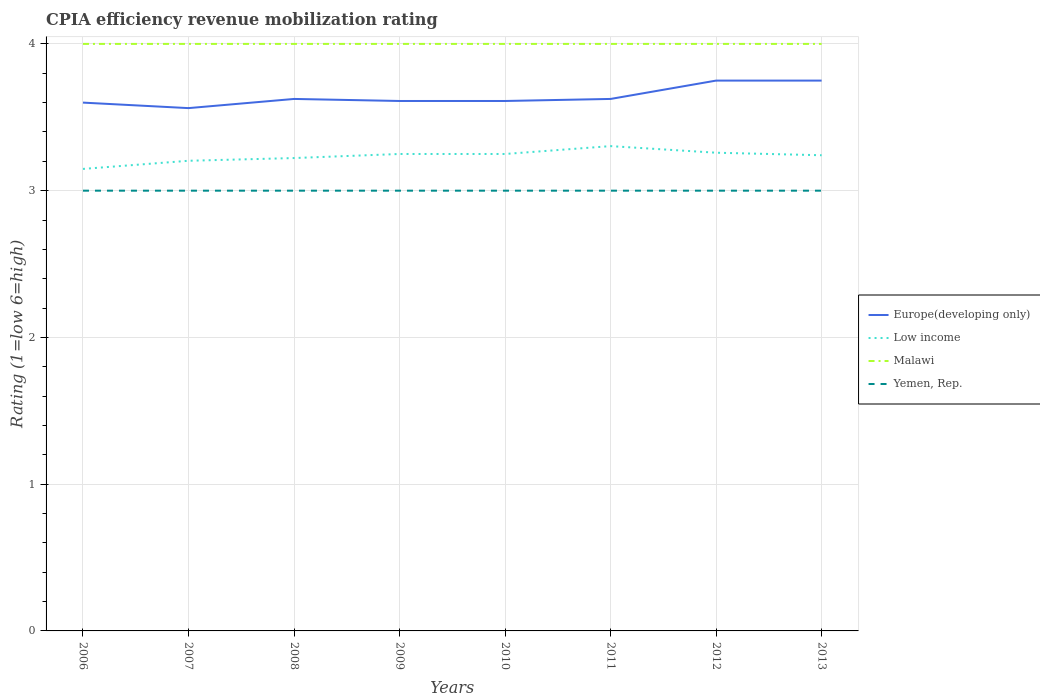Does the line corresponding to Malawi intersect with the line corresponding to Europe(developing only)?
Offer a very short reply. No. Is the number of lines equal to the number of legend labels?
Your answer should be very brief. Yes. Across all years, what is the maximum CPIA rating in Low income?
Ensure brevity in your answer.  3.15. In which year was the CPIA rating in Europe(developing only) maximum?
Your answer should be compact. 2007. What is the total CPIA rating in Europe(developing only) in the graph?
Offer a terse response. -0.02. What is the difference between the highest and the second highest CPIA rating in Malawi?
Your answer should be very brief. 0. Is the CPIA rating in Europe(developing only) strictly greater than the CPIA rating in Malawi over the years?
Provide a short and direct response. Yes. How many years are there in the graph?
Your response must be concise. 8. What is the difference between two consecutive major ticks on the Y-axis?
Offer a very short reply. 1. Does the graph contain any zero values?
Offer a very short reply. No. Does the graph contain grids?
Make the answer very short. Yes. Where does the legend appear in the graph?
Offer a very short reply. Center right. How are the legend labels stacked?
Offer a very short reply. Vertical. What is the title of the graph?
Keep it short and to the point. CPIA efficiency revenue mobilization rating. What is the label or title of the X-axis?
Your answer should be very brief. Years. What is the label or title of the Y-axis?
Your response must be concise. Rating (1=low 6=high). What is the Rating (1=low 6=high) of Low income in 2006?
Offer a very short reply. 3.15. What is the Rating (1=low 6=high) in Yemen, Rep. in 2006?
Ensure brevity in your answer.  3. What is the Rating (1=low 6=high) in Europe(developing only) in 2007?
Your response must be concise. 3.56. What is the Rating (1=low 6=high) of Low income in 2007?
Your answer should be compact. 3.2. What is the Rating (1=low 6=high) in Malawi in 2007?
Keep it short and to the point. 4. What is the Rating (1=low 6=high) of Yemen, Rep. in 2007?
Make the answer very short. 3. What is the Rating (1=low 6=high) of Europe(developing only) in 2008?
Provide a succinct answer. 3.62. What is the Rating (1=low 6=high) in Low income in 2008?
Offer a terse response. 3.22. What is the Rating (1=low 6=high) of Malawi in 2008?
Ensure brevity in your answer.  4. What is the Rating (1=low 6=high) of Europe(developing only) in 2009?
Offer a very short reply. 3.61. What is the Rating (1=low 6=high) of Malawi in 2009?
Ensure brevity in your answer.  4. What is the Rating (1=low 6=high) in Yemen, Rep. in 2009?
Keep it short and to the point. 3. What is the Rating (1=low 6=high) of Europe(developing only) in 2010?
Your response must be concise. 3.61. What is the Rating (1=low 6=high) of Low income in 2010?
Keep it short and to the point. 3.25. What is the Rating (1=low 6=high) of Malawi in 2010?
Offer a very short reply. 4. What is the Rating (1=low 6=high) in Europe(developing only) in 2011?
Your answer should be compact. 3.62. What is the Rating (1=low 6=high) in Low income in 2011?
Ensure brevity in your answer.  3.3. What is the Rating (1=low 6=high) in Malawi in 2011?
Offer a very short reply. 4. What is the Rating (1=low 6=high) in Europe(developing only) in 2012?
Provide a succinct answer. 3.75. What is the Rating (1=low 6=high) of Low income in 2012?
Provide a succinct answer. 3.26. What is the Rating (1=low 6=high) of Europe(developing only) in 2013?
Provide a short and direct response. 3.75. What is the Rating (1=low 6=high) of Low income in 2013?
Offer a terse response. 3.24. What is the Rating (1=low 6=high) in Malawi in 2013?
Your answer should be compact. 4. Across all years, what is the maximum Rating (1=low 6=high) in Europe(developing only)?
Your response must be concise. 3.75. Across all years, what is the maximum Rating (1=low 6=high) in Low income?
Keep it short and to the point. 3.3. Across all years, what is the maximum Rating (1=low 6=high) of Malawi?
Offer a terse response. 4. Across all years, what is the minimum Rating (1=low 6=high) in Europe(developing only)?
Offer a very short reply. 3.56. Across all years, what is the minimum Rating (1=low 6=high) in Low income?
Your response must be concise. 3.15. Across all years, what is the minimum Rating (1=low 6=high) in Malawi?
Your answer should be compact. 4. Across all years, what is the minimum Rating (1=low 6=high) in Yemen, Rep.?
Keep it short and to the point. 3. What is the total Rating (1=low 6=high) of Europe(developing only) in the graph?
Your answer should be compact. 29.13. What is the total Rating (1=low 6=high) in Low income in the graph?
Your answer should be compact. 25.88. What is the total Rating (1=low 6=high) of Malawi in the graph?
Keep it short and to the point. 32. What is the total Rating (1=low 6=high) of Yemen, Rep. in the graph?
Your answer should be compact. 24. What is the difference between the Rating (1=low 6=high) of Europe(developing only) in 2006 and that in 2007?
Ensure brevity in your answer.  0.04. What is the difference between the Rating (1=low 6=high) of Low income in 2006 and that in 2007?
Your response must be concise. -0.06. What is the difference between the Rating (1=low 6=high) of Yemen, Rep. in 2006 and that in 2007?
Your answer should be very brief. 0. What is the difference between the Rating (1=low 6=high) in Europe(developing only) in 2006 and that in 2008?
Offer a very short reply. -0.03. What is the difference between the Rating (1=low 6=high) of Low income in 2006 and that in 2008?
Make the answer very short. -0.07. What is the difference between the Rating (1=low 6=high) in Yemen, Rep. in 2006 and that in 2008?
Offer a terse response. 0. What is the difference between the Rating (1=low 6=high) in Europe(developing only) in 2006 and that in 2009?
Provide a short and direct response. -0.01. What is the difference between the Rating (1=low 6=high) in Low income in 2006 and that in 2009?
Offer a very short reply. -0.1. What is the difference between the Rating (1=low 6=high) in Yemen, Rep. in 2006 and that in 2009?
Offer a very short reply. 0. What is the difference between the Rating (1=low 6=high) of Europe(developing only) in 2006 and that in 2010?
Provide a succinct answer. -0.01. What is the difference between the Rating (1=low 6=high) of Low income in 2006 and that in 2010?
Provide a short and direct response. -0.1. What is the difference between the Rating (1=low 6=high) of Malawi in 2006 and that in 2010?
Make the answer very short. 0. What is the difference between the Rating (1=low 6=high) of Yemen, Rep. in 2006 and that in 2010?
Your answer should be compact. 0. What is the difference between the Rating (1=low 6=high) in Europe(developing only) in 2006 and that in 2011?
Provide a short and direct response. -0.03. What is the difference between the Rating (1=low 6=high) of Low income in 2006 and that in 2011?
Provide a short and direct response. -0.16. What is the difference between the Rating (1=low 6=high) of Yemen, Rep. in 2006 and that in 2011?
Your answer should be very brief. 0. What is the difference between the Rating (1=low 6=high) of Europe(developing only) in 2006 and that in 2012?
Offer a very short reply. -0.15. What is the difference between the Rating (1=low 6=high) in Low income in 2006 and that in 2012?
Keep it short and to the point. -0.11. What is the difference between the Rating (1=low 6=high) of Malawi in 2006 and that in 2012?
Ensure brevity in your answer.  0. What is the difference between the Rating (1=low 6=high) of Yemen, Rep. in 2006 and that in 2012?
Offer a very short reply. 0. What is the difference between the Rating (1=low 6=high) in Europe(developing only) in 2006 and that in 2013?
Ensure brevity in your answer.  -0.15. What is the difference between the Rating (1=low 6=high) of Low income in 2006 and that in 2013?
Offer a terse response. -0.09. What is the difference between the Rating (1=low 6=high) in Malawi in 2006 and that in 2013?
Keep it short and to the point. 0. What is the difference between the Rating (1=low 6=high) in Yemen, Rep. in 2006 and that in 2013?
Provide a succinct answer. 0. What is the difference between the Rating (1=low 6=high) in Europe(developing only) in 2007 and that in 2008?
Your response must be concise. -0.06. What is the difference between the Rating (1=low 6=high) of Low income in 2007 and that in 2008?
Your response must be concise. -0.02. What is the difference between the Rating (1=low 6=high) in Yemen, Rep. in 2007 and that in 2008?
Your answer should be very brief. 0. What is the difference between the Rating (1=low 6=high) in Europe(developing only) in 2007 and that in 2009?
Your answer should be compact. -0.05. What is the difference between the Rating (1=low 6=high) in Low income in 2007 and that in 2009?
Provide a short and direct response. -0.05. What is the difference between the Rating (1=low 6=high) in Yemen, Rep. in 2007 and that in 2009?
Ensure brevity in your answer.  0. What is the difference between the Rating (1=low 6=high) of Europe(developing only) in 2007 and that in 2010?
Offer a terse response. -0.05. What is the difference between the Rating (1=low 6=high) in Low income in 2007 and that in 2010?
Provide a succinct answer. -0.05. What is the difference between the Rating (1=low 6=high) in Europe(developing only) in 2007 and that in 2011?
Give a very brief answer. -0.06. What is the difference between the Rating (1=low 6=high) in Low income in 2007 and that in 2011?
Your answer should be compact. -0.1. What is the difference between the Rating (1=low 6=high) of Malawi in 2007 and that in 2011?
Your response must be concise. 0. What is the difference between the Rating (1=low 6=high) in Europe(developing only) in 2007 and that in 2012?
Your response must be concise. -0.19. What is the difference between the Rating (1=low 6=high) in Low income in 2007 and that in 2012?
Make the answer very short. -0.05. What is the difference between the Rating (1=low 6=high) of Malawi in 2007 and that in 2012?
Your answer should be very brief. 0. What is the difference between the Rating (1=low 6=high) of Europe(developing only) in 2007 and that in 2013?
Make the answer very short. -0.19. What is the difference between the Rating (1=low 6=high) of Low income in 2007 and that in 2013?
Ensure brevity in your answer.  -0.04. What is the difference between the Rating (1=low 6=high) of Malawi in 2007 and that in 2013?
Provide a succinct answer. 0. What is the difference between the Rating (1=low 6=high) of Yemen, Rep. in 2007 and that in 2013?
Keep it short and to the point. 0. What is the difference between the Rating (1=low 6=high) in Europe(developing only) in 2008 and that in 2009?
Provide a succinct answer. 0.01. What is the difference between the Rating (1=low 6=high) of Low income in 2008 and that in 2009?
Your answer should be very brief. -0.03. What is the difference between the Rating (1=low 6=high) in Yemen, Rep. in 2008 and that in 2009?
Offer a very short reply. 0. What is the difference between the Rating (1=low 6=high) in Europe(developing only) in 2008 and that in 2010?
Offer a very short reply. 0.01. What is the difference between the Rating (1=low 6=high) of Low income in 2008 and that in 2010?
Make the answer very short. -0.03. What is the difference between the Rating (1=low 6=high) in Malawi in 2008 and that in 2010?
Provide a short and direct response. 0. What is the difference between the Rating (1=low 6=high) of Europe(developing only) in 2008 and that in 2011?
Make the answer very short. 0. What is the difference between the Rating (1=low 6=high) of Low income in 2008 and that in 2011?
Keep it short and to the point. -0.08. What is the difference between the Rating (1=low 6=high) in Europe(developing only) in 2008 and that in 2012?
Keep it short and to the point. -0.12. What is the difference between the Rating (1=low 6=high) of Low income in 2008 and that in 2012?
Your answer should be compact. -0.04. What is the difference between the Rating (1=low 6=high) of Europe(developing only) in 2008 and that in 2013?
Your answer should be very brief. -0.12. What is the difference between the Rating (1=low 6=high) in Low income in 2008 and that in 2013?
Make the answer very short. -0.02. What is the difference between the Rating (1=low 6=high) of Yemen, Rep. in 2008 and that in 2013?
Your answer should be very brief. 0. What is the difference between the Rating (1=low 6=high) in Europe(developing only) in 2009 and that in 2010?
Your answer should be compact. 0. What is the difference between the Rating (1=low 6=high) in Europe(developing only) in 2009 and that in 2011?
Your answer should be compact. -0.01. What is the difference between the Rating (1=low 6=high) of Low income in 2009 and that in 2011?
Your response must be concise. -0.05. What is the difference between the Rating (1=low 6=high) of Malawi in 2009 and that in 2011?
Offer a terse response. 0. What is the difference between the Rating (1=low 6=high) of Europe(developing only) in 2009 and that in 2012?
Provide a succinct answer. -0.14. What is the difference between the Rating (1=low 6=high) of Low income in 2009 and that in 2012?
Your answer should be very brief. -0.01. What is the difference between the Rating (1=low 6=high) in Yemen, Rep. in 2009 and that in 2012?
Your answer should be very brief. 0. What is the difference between the Rating (1=low 6=high) of Europe(developing only) in 2009 and that in 2013?
Your answer should be very brief. -0.14. What is the difference between the Rating (1=low 6=high) in Low income in 2009 and that in 2013?
Provide a succinct answer. 0.01. What is the difference between the Rating (1=low 6=high) in Malawi in 2009 and that in 2013?
Offer a terse response. 0. What is the difference between the Rating (1=low 6=high) in Yemen, Rep. in 2009 and that in 2013?
Provide a short and direct response. 0. What is the difference between the Rating (1=low 6=high) of Europe(developing only) in 2010 and that in 2011?
Your answer should be very brief. -0.01. What is the difference between the Rating (1=low 6=high) in Low income in 2010 and that in 2011?
Provide a short and direct response. -0.05. What is the difference between the Rating (1=low 6=high) of Malawi in 2010 and that in 2011?
Offer a terse response. 0. What is the difference between the Rating (1=low 6=high) in Yemen, Rep. in 2010 and that in 2011?
Ensure brevity in your answer.  0. What is the difference between the Rating (1=low 6=high) in Europe(developing only) in 2010 and that in 2012?
Your response must be concise. -0.14. What is the difference between the Rating (1=low 6=high) in Low income in 2010 and that in 2012?
Your response must be concise. -0.01. What is the difference between the Rating (1=low 6=high) in Europe(developing only) in 2010 and that in 2013?
Keep it short and to the point. -0.14. What is the difference between the Rating (1=low 6=high) of Low income in 2010 and that in 2013?
Ensure brevity in your answer.  0.01. What is the difference between the Rating (1=low 6=high) in Europe(developing only) in 2011 and that in 2012?
Give a very brief answer. -0.12. What is the difference between the Rating (1=low 6=high) of Low income in 2011 and that in 2012?
Ensure brevity in your answer.  0.04. What is the difference between the Rating (1=low 6=high) in Yemen, Rep. in 2011 and that in 2012?
Keep it short and to the point. 0. What is the difference between the Rating (1=low 6=high) of Europe(developing only) in 2011 and that in 2013?
Make the answer very short. -0.12. What is the difference between the Rating (1=low 6=high) in Low income in 2011 and that in 2013?
Keep it short and to the point. 0.06. What is the difference between the Rating (1=low 6=high) of Yemen, Rep. in 2011 and that in 2013?
Offer a terse response. 0. What is the difference between the Rating (1=low 6=high) in Low income in 2012 and that in 2013?
Your answer should be very brief. 0.02. What is the difference between the Rating (1=low 6=high) of Europe(developing only) in 2006 and the Rating (1=low 6=high) of Low income in 2007?
Keep it short and to the point. 0.4. What is the difference between the Rating (1=low 6=high) in Europe(developing only) in 2006 and the Rating (1=low 6=high) in Yemen, Rep. in 2007?
Your answer should be compact. 0.6. What is the difference between the Rating (1=low 6=high) in Low income in 2006 and the Rating (1=low 6=high) in Malawi in 2007?
Keep it short and to the point. -0.85. What is the difference between the Rating (1=low 6=high) in Low income in 2006 and the Rating (1=low 6=high) in Yemen, Rep. in 2007?
Your answer should be very brief. 0.15. What is the difference between the Rating (1=low 6=high) in Europe(developing only) in 2006 and the Rating (1=low 6=high) in Low income in 2008?
Keep it short and to the point. 0.38. What is the difference between the Rating (1=low 6=high) of Low income in 2006 and the Rating (1=low 6=high) of Malawi in 2008?
Give a very brief answer. -0.85. What is the difference between the Rating (1=low 6=high) of Low income in 2006 and the Rating (1=low 6=high) of Yemen, Rep. in 2008?
Give a very brief answer. 0.15. What is the difference between the Rating (1=low 6=high) of Malawi in 2006 and the Rating (1=low 6=high) of Yemen, Rep. in 2008?
Provide a short and direct response. 1. What is the difference between the Rating (1=low 6=high) in Europe(developing only) in 2006 and the Rating (1=low 6=high) in Low income in 2009?
Offer a terse response. 0.35. What is the difference between the Rating (1=low 6=high) of Europe(developing only) in 2006 and the Rating (1=low 6=high) of Yemen, Rep. in 2009?
Keep it short and to the point. 0.6. What is the difference between the Rating (1=low 6=high) in Low income in 2006 and the Rating (1=low 6=high) in Malawi in 2009?
Make the answer very short. -0.85. What is the difference between the Rating (1=low 6=high) of Low income in 2006 and the Rating (1=low 6=high) of Yemen, Rep. in 2009?
Provide a succinct answer. 0.15. What is the difference between the Rating (1=low 6=high) in Malawi in 2006 and the Rating (1=low 6=high) in Yemen, Rep. in 2009?
Provide a short and direct response. 1. What is the difference between the Rating (1=low 6=high) of Low income in 2006 and the Rating (1=low 6=high) of Malawi in 2010?
Ensure brevity in your answer.  -0.85. What is the difference between the Rating (1=low 6=high) in Low income in 2006 and the Rating (1=low 6=high) in Yemen, Rep. in 2010?
Keep it short and to the point. 0.15. What is the difference between the Rating (1=low 6=high) of Malawi in 2006 and the Rating (1=low 6=high) of Yemen, Rep. in 2010?
Provide a short and direct response. 1. What is the difference between the Rating (1=low 6=high) in Europe(developing only) in 2006 and the Rating (1=low 6=high) in Low income in 2011?
Make the answer very short. 0.3. What is the difference between the Rating (1=low 6=high) of Europe(developing only) in 2006 and the Rating (1=low 6=high) of Malawi in 2011?
Your response must be concise. -0.4. What is the difference between the Rating (1=low 6=high) in Europe(developing only) in 2006 and the Rating (1=low 6=high) in Yemen, Rep. in 2011?
Offer a terse response. 0.6. What is the difference between the Rating (1=low 6=high) in Low income in 2006 and the Rating (1=low 6=high) in Malawi in 2011?
Provide a succinct answer. -0.85. What is the difference between the Rating (1=low 6=high) of Low income in 2006 and the Rating (1=low 6=high) of Yemen, Rep. in 2011?
Ensure brevity in your answer.  0.15. What is the difference between the Rating (1=low 6=high) in Malawi in 2006 and the Rating (1=low 6=high) in Yemen, Rep. in 2011?
Provide a short and direct response. 1. What is the difference between the Rating (1=low 6=high) in Europe(developing only) in 2006 and the Rating (1=low 6=high) in Low income in 2012?
Offer a very short reply. 0.34. What is the difference between the Rating (1=low 6=high) of Europe(developing only) in 2006 and the Rating (1=low 6=high) of Malawi in 2012?
Provide a succinct answer. -0.4. What is the difference between the Rating (1=low 6=high) of Europe(developing only) in 2006 and the Rating (1=low 6=high) of Yemen, Rep. in 2012?
Your answer should be compact. 0.6. What is the difference between the Rating (1=low 6=high) of Low income in 2006 and the Rating (1=low 6=high) of Malawi in 2012?
Ensure brevity in your answer.  -0.85. What is the difference between the Rating (1=low 6=high) in Low income in 2006 and the Rating (1=low 6=high) in Yemen, Rep. in 2012?
Your answer should be very brief. 0.15. What is the difference between the Rating (1=low 6=high) of Malawi in 2006 and the Rating (1=low 6=high) of Yemen, Rep. in 2012?
Ensure brevity in your answer.  1. What is the difference between the Rating (1=low 6=high) of Europe(developing only) in 2006 and the Rating (1=low 6=high) of Low income in 2013?
Give a very brief answer. 0.36. What is the difference between the Rating (1=low 6=high) of Europe(developing only) in 2006 and the Rating (1=low 6=high) of Malawi in 2013?
Make the answer very short. -0.4. What is the difference between the Rating (1=low 6=high) in Europe(developing only) in 2006 and the Rating (1=low 6=high) in Yemen, Rep. in 2013?
Your answer should be compact. 0.6. What is the difference between the Rating (1=low 6=high) of Low income in 2006 and the Rating (1=low 6=high) of Malawi in 2013?
Keep it short and to the point. -0.85. What is the difference between the Rating (1=low 6=high) of Low income in 2006 and the Rating (1=low 6=high) of Yemen, Rep. in 2013?
Make the answer very short. 0.15. What is the difference between the Rating (1=low 6=high) in Europe(developing only) in 2007 and the Rating (1=low 6=high) in Low income in 2008?
Give a very brief answer. 0.34. What is the difference between the Rating (1=low 6=high) of Europe(developing only) in 2007 and the Rating (1=low 6=high) of Malawi in 2008?
Make the answer very short. -0.44. What is the difference between the Rating (1=low 6=high) of Europe(developing only) in 2007 and the Rating (1=low 6=high) of Yemen, Rep. in 2008?
Provide a succinct answer. 0.56. What is the difference between the Rating (1=low 6=high) in Low income in 2007 and the Rating (1=low 6=high) in Malawi in 2008?
Offer a terse response. -0.8. What is the difference between the Rating (1=low 6=high) in Low income in 2007 and the Rating (1=low 6=high) in Yemen, Rep. in 2008?
Make the answer very short. 0.2. What is the difference between the Rating (1=low 6=high) in Malawi in 2007 and the Rating (1=low 6=high) in Yemen, Rep. in 2008?
Offer a very short reply. 1. What is the difference between the Rating (1=low 6=high) of Europe(developing only) in 2007 and the Rating (1=low 6=high) of Low income in 2009?
Provide a succinct answer. 0.31. What is the difference between the Rating (1=low 6=high) of Europe(developing only) in 2007 and the Rating (1=low 6=high) of Malawi in 2009?
Provide a succinct answer. -0.44. What is the difference between the Rating (1=low 6=high) in Europe(developing only) in 2007 and the Rating (1=low 6=high) in Yemen, Rep. in 2009?
Offer a terse response. 0.56. What is the difference between the Rating (1=low 6=high) of Low income in 2007 and the Rating (1=low 6=high) of Malawi in 2009?
Give a very brief answer. -0.8. What is the difference between the Rating (1=low 6=high) of Low income in 2007 and the Rating (1=low 6=high) of Yemen, Rep. in 2009?
Offer a very short reply. 0.2. What is the difference between the Rating (1=low 6=high) of Europe(developing only) in 2007 and the Rating (1=low 6=high) of Low income in 2010?
Make the answer very short. 0.31. What is the difference between the Rating (1=low 6=high) of Europe(developing only) in 2007 and the Rating (1=low 6=high) of Malawi in 2010?
Give a very brief answer. -0.44. What is the difference between the Rating (1=low 6=high) in Europe(developing only) in 2007 and the Rating (1=low 6=high) in Yemen, Rep. in 2010?
Give a very brief answer. 0.56. What is the difference between the Rating (1=low 6=high) of Low income in 2007 and the Rating (1=low 6=high) of Malawi in 2010?
Ensure brevity in your answer.  -0.8. What is the difference between the Rating (1=low 6=high) of Low income in 2007 and the Rating (1=low 6=high) of Yemen, Rep. in 2010?
Your answer should be compact. 0.2. What is the difference between the Rating (1=low 6=high) of Europe(developing only) in 2007 and the Rating (1=low 6=high) of Low income in 2011?
Provide a succinct answer. 0.26. What is the difference between the Rating (1=low 6=high) in Europe(developing only) in 2007 and the Rating (1=low 6=high) in Malawi in 2011?
Your response must be concise. -0.44. What is the difference between the Rating (1=low 6=high) in Europe(developing only) in 2007 and the Rating (1=low 6=high) in Yemen, Rep. in 2011?
Your answer should be compact. 0.56. What is the difference between the Rating (1=low 6=high) of Low income in 2007 and the Rating (1=low 6=high) of Malawi in 2011?
Ensure brevity in your answer.  -0.8. What is the difference between the Rating (1=low 6=high) of Low income in 2007 and the Rating (1=low 6=high) of Yemen, Rep. in 2011?
Keep it short and to the point. 0.2. What is the difference between the Rating (1=low 6=high) in Europe(developing only) in 2007 and the Rating (1=low 6=high) in Low income in 2012?
Your response must be concise. 0.3. What is the difference between the Rating (1=low 6=high) in Europe(developing only) in 2007 and the Rating (1=low 6=high) in Malawi in 2012?
Your response must be concise. -0.44. What is the difference between the Rating (1=low 6=high) in Europe(developing only) in 2007 and the Rating (1=low 6=high) in Yemen, Rep. in 2012?
Give a very brief answer. 0.56. What is the difference between the Rating (1=low 6=high) in Low income in 2007 and the Rating (1=low 6=high) in Malawi in 2012?
Offer a terse response. -0.8. What is the difference between the Rating (1=low 6=high) of Low income in 2007 and the Rating (1=low 6=high) of Yemen, Rep. in 2012?
Make the answer very short. 0.2. What is the difference between the Rating (1=low 6=high) in Europe(developing only) in 2007 and the Rating (1=low 6=high) in Low income in 2013?
Your answer should be compact. 0.32. What is the difference between the Rating (1=low 6=high) of Europe(developing only) in 2007 and the Rating (1=low 6=high) of Malawi in 2013?
Keep it short and to the point. -0.44. What is the difference between the Rating (1=low 6=high) in Europe(developing only) in 2007 and the Rating (1=low 6=high) in Yemen, Rep. in 2013?
Your answer should be compact. 0.56. What is the difference between the Rating (1=low 6=high) in Low income in 2007 and the Rating (1=low 6=high) in Malawi in 2013?
Provide a short and direct response. -0.8. What is the difference between the Rating (1=low 6=high) of Low income in 2007 and the Rating (1=low 6=high) of Yemen, Rep. in 2013?
Provide a succinct answer. 0.2. What is the difference between the Rating (1=low 6=high) of Malawi in 2007 and the Rating (1=low 6=high) of Yemen, Rep. in 2013?
Keep it short and to the point. 1. What is the difference between the Rating (1=low 6=high) in Europe(developing only) in 2008 and the Rating (1=low 6=high) in Low income in 2009?
Offer a terse response. 0.38. What is the difference between the Rating (1=low 6=high) of Europe(developing only) in 2008 and the Rating (1=low 6=high) of Malawi in 2009?
Make the answer very short. -0.38. What is the difference between the Rating (1=low 6=high) in Europe(developing only) in 2008 and the Rating (1=low 6=high) in Yemen, Rep. in 2009?
Offer a terse response. 0.62. What is the difference between the Rating (1=low 6=high) in Low income in 2008 and the Rating (1=low 6=high) in Malawi in 2009?
Ensure brevity in your answer.  -0.78. What is the difference between the Rating (1=low 6=high) of Low income in 2008 and the Rating (1=low 6=high) of Yemen, Rep. in 2009?
Provide a succinct answer. 0.22. What is the difference between the Rating (1=low 6=high) of Malawi in 2008 and the Rating (1=low 6=high) of Yemen, Rep. in 2009?
Offer a very short reply. 1. What is the difference between the Rating (1=low 6=high) of Europe(developing only) in 2008 and the Rating (1=low 6=high) of Malawi in 2010?
Ensure brevity in your answer.  -0.38. What is the difference between the Rating (1=low 6=high) of Europe(developing only) in 2008 and the Rating (1=low 6=high) of Yemen, Rep. in 2010?
Your response must be concise. 0.62. What is the difference between the Rating (1=low 6=high) in Low income in 2008 and the Rating (1=low 6=high) in Malawi in 2010?
Your answer should be compact. -0.78. What is the difference between the Rating (1=low 6=high) in Low income in 2008 and the Rating (1=low 6=high) in Yemen, Rep. in 2010?
Give a very brief answer. 0.22. What is the difference between the Rating (1=low 6=high) in Europe(developing only) in 2008 and the Rating (1=low 6=high) in Low income in 2011?
Give a very brief answer. 0.32. What is the difference between the Rating (1=low 6=high) of Europe(developing only) in 2008 and the Rating (1=low 6=high) of Malawi in 2011?
Offer a very short reply. -0.38. What is the difference between the Rating (1=low 6=high) of Low income in 2008 and the Rating (1=low 6=high) of Malawi in 2011?
Provide a short and direct response. -0.78. What is the difference between the Rating (1=low 6=high) in Low income in 2008 and the Rating (1=low 6=high) in Yemen, Rep. in 2011?
Ensure brevity in your answer.  0.22. What is the difference between the Rating (1=low 6=high) in Europe(developing only) in 2008 and the Rating (1=low 6=high) in Low income in 2012?
Offer a very short reply. 0.37. What is the difference between the Rating (1=low 6=high) in Europe(developing only) in 2008 and the Rating (1=low 6=high) in Malawi in 2012?
Make the answer very short. -0.38. What is the difference between the Rating (1=low 6=high) in Low income in 2008 and the Rating (1=low 6=high) in Malawi in 2012?
Your response must be concise. -0.78. What is the difference between the Rating (1=low 6=high) of Low income in 2008 and the Rating (1=low 6=high) of Yemen, Rep. in 2012?
Provide a succinct answer. 0.22. What is the difference between the Rating (1=low 6=high) in Malawi in 2008 and the Rating (1=low 6=high) in Yemen, Rep. in 2012?
Give a very brief answer. 1. What is the difference between the Rating (1=low 6=high) of Europe(developing only) in 2008 and the Rating (1=low 6=high) of Low income in 2013?
Your answer should be compact. 0.38. What is the difference between the Rating (1=low 6=high) in Europe(developing only) in 2008 and the Rating (1=low 6=high) in Malawi in 2013?
Provide a short and direct response. -0.38. What is the difference between the Rating (1=low 6=high) in Low income in 2008 and the Rating (1=low 6=high) in Malawi in 2013?
Offer a terse response. -0.78. What is the difference between the Rating (1=low 6=high) of Low income in 2008 and the Rating (1=low 6=high) of Yemen, Rep. in 2013?
Give a very brief answer. 0.22. What is the difference between the Rating (1=low 6=high) in Malawi in 2008 and the Rating (1=low 6=high) in Yemen, Rep. in 2013?
Ensure brevity in your answer.  1. What is the difference between the Rating (1=low 6=high) in Europe(developing only) in 2009 and the Rating (1=low 6=high) in Low income in 2010?
Make the answer very short. 0.36. What is the difference between the Rating (1=low 6=high) of Europe(developing only) in 2009 and the Rating (1=low 6=high) of Malawi in 2010?
Your response must be concise. -0.39. What is the difference between the Rating (1=low 6=high) of Europe(developing only) in 2009 and the Rating (1=low 6=high) of Yemen, Rep. in 2010?
Your response must be concise. 0.61. What is the difference between the Rating (1=low 6=high) in Low income in 2009 and the Rating (1=low 6=high) in Malawi in 2010?
Your answer should be very brief. -0.75. What is the difference between the Rating (1=low 6=high) of Europe(developing only) in 2009 and the Rating (1=low 6=high) of Low income in 2011?
Provide a succinct answer. 0.31. What is the difference between the Rating (1=low 6=high) of Europe(developing only) in 2009 and the Rating (1=low 6=high) of Malawi in 2011?
Your response must be concise. -0.39. What is the difference between the Rating (1=low 6=high) of Europe(developing only) in 2009 and the Rating (1=low 6=high) of Yemen, Rep. in 2011?
Your response must be concise. 0.61. What is the difference between the Rating (1=low 6=high) of Low income in 2009 and the Rating (1=low 6=high) of Malawi in 2011?
Ensure brevity in your answer.  -0.75. What is the difference between the Rating (1=low 6=high) of Europe(developing only) in 2009 and the Rating (1=low 6=high) of Low income in 2012?
Offer a terse response. 0.35. What is the difference between the Rating (1=low 6=high) in Europe(developing only) in 2009 and the Rating (1=low 6=high) in Malawi in 2012?
Provide a short and direct response. -0.39. What is the difference between the Rating (1=low 6=high) in Europe(developing only) in 2009 and the Rating (1=low 6=high) in Yemen, Rep. in 2012?
Keep it short and to the point. 0.61. What is the difference between the Rating (1=low 6=high) in Low income in 2009 and the Rating (1=low 6=high) in Malawi in 2012?
Provide a short and direct response. -0.75. What is the difference between the Rating (1=low 6=high) in Malawi in 2009 and the Rating (1=low 6=high) in Yemen, Rep. in 2012?
Offer a terse response. 1. What is the difference between the Rating (1=low 6=high) in Europe(developing only) in 2009 and the Rating (1=low 6=high) in Low income in 2013?
Provide a short and direct response. 0.37. What is the difference between the Rating (1=low 6=high) of Europe(developing only) in 2009 and the Rating (1=low 6=high) of Malawi in 2013?
Your response must be concise. -0.39. What is the difference between the Rating (1=low 6=high) in Europe(developing only) in 2009 and the Rating (1=low 6=high) in Yemen, Rep. in 2013?
Give a very brief answer. 0.61. What is the difference between the Rating (1=low 6=high) of Low income in 2009 and the Rating (1=low 6=high) of Malawi in 2013?
Your answer should be very brief. -0.75. What is the difference between the Rating (1=low 6=high) of Low income in 2009 and the Rating (1=low 6=high) of Yemen, Rep. in 2013?
Give a very brief answer. 0.25. What is the difference between the Rating (1=low 6=high) of Malawi in 2009 and the Rating (1=low 6=high) of Yemen, Rep. in 2013?
Offer a very short reply. 1. What is the difference between the Rating (1=low 6=high) in Europe(developing only) in 2010 and the Rating (1=low 6=high) in Low income in 2011?
Give a very brief answer. 0.31. What is the difference between the Rating (1=low 6=high) in Europe(developing only) in 2010 and the Rating (1=low 6=high) in Malawi in 2011?
Keep it short and to the point. -0.39. What is the difference between the Rating (1=low 6=high) in Europe(developing only) in 2010 and the Rating (1=low 6=high) in Yemen, Rep. in 2011?
Your response must be concise. 0.61. What is the difference between the Rating (1=low 6=high) in Low income in 2010 and the Rating (1=low 6=high) in Malawi in 2011?
Your answer should be compact. -0.75. What is the difference between the Rating (1=low 6=high) of Europe(developing only) in 2010 and the Rating (1=low 6=high) of Low income in 2012?
Your response must be concise. 0.35. What is the difference between the Rating (1=low 6=high) in Europe(developing only) in 2010 and the Rating (1=low 6=high) in Malawi in 2012?
Provide a short and direct response. -0.39. What is the difference between the Rating (1=low 6=high) of Europe(developing only) in 2010 and the Rating (1=low 6=high) of Yemen, Rep. in 2012?
Your answer should be compact. 0.61. What is the difference between the Rating (1=low 6=high) in Low income in 2010 and the Rating (1=low 6=high) in Malawi in 2012?
Provide a short and direct response. -0.75. What is the difference between the Rating (1=low 6=high) of Low income in 2010 and the Rating (1=low 6=high) of Yemen, Rep. in 2012?
Offer a very short reply. 0.25. What is the difference between the Rating (1=low 6=high) in Malawi in 2010 and the Rating (1=low 6=high) in Yemen, Rep. in 2012?
Offer a terse response. 1. What is the difference between the Rating (1=low 6=high) of Europe(developing only) in 2010 and the Rating (1=low 6=high) of Low income in 2013?
Provide a short and direct response. 0.37. What is the difference between the Rating (1=low 6=high) of Europe(developing only) in 2010 and the Rating (1=low 6=high) of Malawi in 2013?
Provide a succinct answer. -0.39. What is the difference between the Rating (1=low 6=high) in Europe(developing only) in 2010 and the Rating (1=low 6=high) in Yemen, Rep. in 2013?
Keep it short and to the point. 0.61. What is the difference between the Rating (1=low 6=high) of Low income in 2010 and the Rating (1=low 6=high) of Malawi in 2013?
Keep it short and to the point. -0.75. What is the difference between the Rating (1=low 6=high) of Europe(developing only) in 2011 and the Rating (1=low 6=high) of Low income in 2012?
Your answer should be compact. 0.37. What is the difference between the Rating (1=low 6=high) in Europe(developing only) in 2011 and the Rating (1=low 6=high) in Malawi in 2012?
Provide a short and direct response. -0.38. What is the difference between the Rating (1=low 6=high) in Low income in 2011 and the Rating (1=low 6=high) in Malawi in 2012?
Your answer should be compact. -0.7. What is the difference between the Rating (1=low 6=high) in Low income in 2011 and the Rating (1=low 6=high) in Yemen, Rep. in 2012?
Your answer should be compact. 0.3. What is the difference between the Rating (1=low 6=high) of Malawi in 2011 and the Rating (1=low 6=high) of Yemen, Rep. in 2012?
Keep it short and to the point. 1. What is the difference between the Rating (1=low 6=high) in Europe(developing only) in 2011 and the Rating (1=low 6=high) in Low income in 2013?
Make the answer very short. 0.38. What is the difference between the Rating (1=low 6=high) of Europe(developing only) in 2011 and the Rating (1=low 6=high) of Malawi in 2013?
Provide a succinct answer. -0.38. What is the difference between the Rating (1=low 6=high) in Low income in 2011 and the Rating (1=low 6=high) in Malawi in 2013?
Ensure brevity in your answer.  -0.7. What is the difference between the Rating (1=low 6=high) of Low income in 2011 and the Rating (1=low 6=high) of Yemen, Rep. in 2013?
Give a very brief answer. 0.3. What is the difference between the Rating (1=low 6=high) in Europe(developing only) in 2012 and the Rating (1=low 6=high) in Low income in 2013?
Give a very brief answer. 0.51. What is the difference between the Rating (1=low 6=high) in Europe(developing only) in 2012 and the Rating (1=low 6=high) in Malawi in 2013?
Offer a terse response. -0.25. What is the difference between the Rating (1=low 6=high) in Europe(developing only) in 2012 and the Rating (1=low 6=high) in Yemen, Rep. in 2013?
Your response must be concise. 0.75. What is the difference between the Rating (1=low 6=high) in Low income in 2012 and the Rating (1=low 6=high) in Malawi in 2013?
Make the answer very short. -0.74. What is the difference between the Rating (1=low 6=high) of Low income in 2012 and the Rating (1=low 6=high) of Yemen, Rep. in 2013?
Your answer should be very brief. 0.26. What is the difference between the Rating (1=low 6=high) in Malawi in 2012 and the Rating (1=low 6=high) in Yemen, Rep. in 2013?
Give a very brief answer. 1. What is the average Rating (1=low 6=high) in Europe(developing only) per year?
Your answer should be compact. 3.64. What is the average Rating (1=low 6=high) in Low income per year?
Your answer should be very brief. 3.23. What is the average Rating (1=low 6=high) in Malawi per year?
Ensure brevity in your answer.  4. What is the average Rating (1=low 6=high) in Yemen, Rep. per year?
Provide a short and direct response. 3. In the year 2006, what is the difference between the Rating (1=low 6=high) in Europe(developing only) and Rating (1=low 6=high) in Low income?
Your response must be concise. 0.45. In the year 2006, what is the difference between the Rating (1=low 6=high) in Europe(developing only) and Rating (1=low 6=high) in Yemen, Rep.?
Keep it short and to the point. 0.6. In the year 2006, what is the difference between the Rating (1=low 6=high) in Low income and Rating (1=low 6=high) in Malawi?
Provide a short and direct response. -0.85. In the year 2006, what is the difference between the Rating (1=low 6=high) in Low income and Rating (1=low 6=high) in Yemen, Rep.?
Offer a terse response. 0.15. In the year 2007, what is the difference between the Rating (1=low 6=high) in Europe(developing only) and Rating (1=low 6=high) in Low income?
Ensure brevity in your answer.  0.36. In the year 2007, what is the difference between the Rating (1=low 6=high) in Europe(developing only) and Rating (1=low 6=high) in Malawi?
Your answer should be compact. -0.44. In the year 2007, what is the difference between the Rating (1=low 6=high) of Europe(developing only) and Rating (1=low 6=high) of Yemen, Rep.?
Your response must be concise. 0.56. In the year 2007, what is the difference between the Rating (1=low 6=high) of Low income and Rating (1=low 6=high) of Malawi?
Your answer should be very brief. -0.8. In the year 2007, what is the difference between the Rating (1=low 6=high) of Low income and Rating (1=low 6=high) of Yemen, Rep.?
Give a very brief answer. 0.2. In the year 2008, what is the difference between the Rating (1=low 6=high) in Europe(developing only) and Rating (1=low 6=high) in Low income?
Ensure brevity in your answer.  0.4. In the year 2008, what is the difference between the Rating (1=low 6=high) in Europe(developing only) and Rating (1=low 6=high) in Malawi?
Your answer should be very brief. -0.38. In the year 2008, what is the difference between the Rating (1=low 6=high) of Europe(developing only) and Rating (1=low 6=high) of Yemen, Rep.?
Your answer should be compact. 0.62. In the year 2008, what is the difference between the Rating (1=low 6=high) of Low income and Rating (1=low 6=high) of Malawi?
Provide a succinct answer. -0.78. In the year 2008, what is the difference between the Rating (1=low 6=high) in Low income and Rating (1=low 6=high) in Yemen, Rep.?
Offer a terse response. 0.22. In the year 2008, what is the difference between the Rating (1=low 6=high) of Malawi and Rating (1=low 6=high) of Yemen, Rep.?
Provide a succinct answer. 1. In the year 2009, what is the difference between the Rating (1=low 6=high) of Europe(developing only) and Rating (1=low 6=high) of Low income?
Offer a very short reply. 0.36. In the year 2009, what is the difference between the Rating (1=low 6=high) of Europe(developing only) and Rating (1=low 6=high) of Malawi?
Provide a succinct answer. -0.39. In the year 2009, what is the difference between the Rating (1=low 6=high) in Europe(developing only) and Rating (1=low 6=high) in Yemen, Rep.?
Give a very brief answer. 0.61. In the year 2009, what is the difference between the Rating (1=low 6=high) in Low income and Rating (1=low 6=high) in Malawi?
Your answer should be very brief. -0.75. In the year 2009, what is the difference between the Rating (1=low 6=high) in Malawi and Rating (1=low 6=high) in Yemen, Rep.?
Offer a terse response. 1. In the year 2010, what is the difference between the Rating (1=low 6=high) of Europe(developing only) and Rating (1=low 6=high) of Low income?
Keep it short and to the point. 0.36. In the year 2010, what is the difference between the Rating (1=low 6=high) of Europe(developing only) and Rating (1=low 6=high) of Malawi?
Give a very brief answer. -0.39. In the year 2010, what is the difference between the Rating (1=low 6=high) of Europe(developing only) and Rating (1=low 6=high) of Yemen, Rep.?
Your response must be concise. 0.61. In the year 2010, what is the difference between the Rating (1=low 6=high) in Low income and Rating (1=low 6=high) in Malawi?
Offer a terse response. -0.75. In the year 2010, what is the difference between the Rating (1=low 6=high) in Low income and Rating (1=low 6=high) in Yemen, Rep.?
Offer a very short reply. 0.25. In the year 2010, what is the difference between the Rating (1=low 6=high) in Malawi and Rating (1=low 6=high) in Yemen, Rep.?
Give a very brief answer. 1. In the year 2011, what is the difference between the Rating (1=low 6=high) in Europe(developing only) and Rating (1=low 6=high) in Low income?
Make the answer very short. 0.32. In the year 2011, what is the difference between the Rating (1=low 6=high) in Europe(developing only) and Rating (1=low 6=high) in Malawi?
Offer a terse response. -0.38. In the year 2011, what is the difference between the Rating (1=low 6=high) in Europe(developing only) and Rating (1=low 6=high) in Yemen, Rep.?
Keep it short and to the point. 0.62. In the year 2011, what is the difference between the Rating (1=low 6=high) of Low income and Rating (1=low 6=high) of Malawi?
Your answer should be very brief. -0.7. In the year 2011, what is the difference between the Rating (1=low 6=high) in Low income and Rating (1=low 6=high) in Yemen, Rep.?
Offer a very short reply. 0.3. In the year 2011, what is the difference between the Rating (1=low 6=high) in Malawi and Rating (1=low 6=high) in Yemen, Rep.?
Give a very brief answer. 1. In the year 2012, what is the difference between the Rating (1=low 6=high) in Europe(developing only) and Rating (1=low 6=high) in Low income?
Keep it short and to the point. 0.49. In the year 2012, what is the difference between the Rating (1=low 6=high) of Europe(developing only) and Rating (1=low 6=high) of Yemen, Rep.?
Make the answer very short. 0.75. In the year 2012, what is the difference between the Rating (1=low 6=high) of Low income and Rating (1=low 6=high) of Malawi?
Make the answer very short. -0.74. In the year 2012, what is the difference between the Rating (1=low 6=high) of Low income and Rating (1=low 6=high) of Yemen, Rep.?
Offer a very short reply. 0.26. In the year 2012, what is the difference between the Rating (1=low 6=high) in Malawi and Rating (1=low 6=high) in Yemen, Rep.?
Give a very brief answer. 1. In the year 2013, what is the difference between the Rating (1=low 6=high) of Europe(developing only) and Rating (1=low 6=high) of Low income?
Offer a very short reply. 0.51. In the year 2013, what is the difference between the Rating (1=low 6=high) in Europe(developing only) and Rating (1=low 6=high) in Malawi?
Offer a terse response. -0.25. In the year 2013, what is the difference between the Rating (1=low 6=high) in Low income and Rating (1=low 6=high) in Malawi?
Your response must be concise. -0.76. In the year 2013, what is the difference between the Rating (1=low 6=high) of Low income and Rating (1=low 6=high) of Yemen, Rep.?
Make the answer very short. 0.24. What is the ratio of the Rating (1=low 6=high) in Europe(developing only) in 2006 to that in 2007?
Give a very brief answer. 1.01. What is the ratio of the Rating (1=low 6=high) of Low income in 2006 to that in 2007?
Ensure brevity in your answer.  0.98. What is the ratio of the Rating (1=low 6=high) of Malawi in 2006 to that in 2007?
Your response must be concise. 1. What is the ratio of the Rating (1=low 6=high) of Yemen, Rep. in 2006 to that in 2008?
Provide a short and direct response. 1. What is the ratio of the Rating (1=low 6=high) of Low income in 2006 to that in 2009?
Offer a very short reply. 0.97. What is the ratio of the Rating (1=low 6=high) of Malawi in 2006 to that in 2009?
Provide a succinct answer. 1. What is the ratio of the Rating (1=low 6=high) in Yemen, Rep. in 2006 to that in 2009?
Your answer should be compact. 1. What is the ratio of the Rating (1=low 6=high) in Low income in 2006 to that in 2010?
Provide a short and direct response. 0.97. What is the ratio of the Rating (1=low 6=high) in Yemen, Rep. in 2006 to that in 2010?
Offer a terse response. 1. What is the ratio of the Rating (1=low 6=high) of Europe(developing only) in 2006 to that in 2011?
Ensure brevity in your answer.  0.99. What is the ratio of the Rating (1=low 6=high) in Low income in 2006 to that in 2011?
Your response must be concise. 0.95. What is the ratio of the Rating (1=low 6=high) in Malawi in 2006 to that in 2011?
Keep it short and to the point. 1. What is the ratio of the Rating (1=low 6=high) of Europe(developing only) in 2006 to that in 2012?
Provide a short and direct response. 0.96. What is the ratio of the Rating (1=low 6=high) of Low income in 2006 to that in 2012?
Offer a terse response. 0.97. What is the ratio of the Rating (1=low 6=high) in Yemen, Rep. in 2006 to that in 2012?
Your response must be concise. 1. What is the ratio of the Rating (1=low 6=high) in Europe(developing only) in 2006 to that in 2013?
Make the answer very short. 0.96. What is the ratio of the Rating (1=low 6=high) of Low income in 2006 to that in 2013?
Make the answer very short. 0.97. What is the ratio of the Rating (1=low 6=high) in Yemen, Rep. in 2006 to that in 2013?
Give a very brief answer. 1. What is the ratio of the Rating (1=low 6=high) in Europe(developing only) in 2007 to that in 2008?
Make the answer very short. 0.98. What is the ratio of the Rating (1=low 6=high) of Yemen, Rep. in 2007 to that in 2008?
Give a very brief answer. 1. What is the ratio of the Rating (1=low 6=high) in Europe(developing only) in 2007 to that in 2009?
Offer a very short reply. 0.99. What is the ratio of the Rating (1=low 6=high) in Low income in 2007 to that in 2009?
Ensure brevity in your answer.  0.99. What is the ratio of the Rating (1=low 6=high) of Europe(developing only) in 2007 to that in 2010?
Keep it short and to the point. 0.99. What is the ratio of the Rating (1=low 6=high) of Low income in 2007 to that in 2010?
Provide a short and direct response. 0.99. What is the ratio of the Rating (1=low 6=high) of Malawi in 2007 to that in 2010?
Your answer should be very brief. 1. What is the ratio of the Rating (1=low 6=high) of Yemen, Rep. in 2007 to that in 2010?
Offer a very short reply. 1. What is the ratio of the Rating (1=low 6=high) in Europe(developing only) in 2007 to that in 2011?
Offer a very short reply. 0.98. What is the ratio of the Rating (1=low 6=high) of Low income in 2007 to that in 2011?
Your response must be concise. 0.97. What is the ratio of the Rating (1=low 6=high) of Malawi in 2007 to that in 2011?
Offer a terse response. 1. What is the ratio of the Rating (1=low 6=high) of Low income in 2007 to that in 2012?
Give a very brief answer. 0.98. What is the ratio of the Rating (1=low 6=high) in Europe(developing only) in 2007 to that in 2013?
Provide a short and direct response. 0.95. What is the ratio of the Rating (1=low 6=high) of Low income in 2007 to that in 2013?
Ensure brevity in your answer.  0.99. What is the ratio of the Rating (1=low 6=high) in Yemen, Rep. in 2007 to that in 2013?
Ensure brevity in your answer.  1. What is the ratio of the Rating (1=low 6=high) in Europe(developing only) in 2008 to that in 2009?
Your answer should be very brief. 1. What is the ratio of the Rating (1=low 6=high) in Low income in 2008 to that in 2009?
Keep it short and to the point. 0.99. What is the ratio of the Rating (1=low 6=high) of Malawi in 2008 to that in 2009?
Provide a succinct answer. 1. What is the ratio of the Rating (1=low 6=high) in Malawi in 2008 to that in 2010?
Offer a very short reply. 1. What is the ratio of the Rating (1=low 6=high) in Low income in 2008 to that in 2011?
Your response must be concise. 0.98. What is the ratio of the Rating (1=low 6=high) of Yemen, Rep. in 2008 to that in 2011?
Your answer should be very brief. 1. What is the ratio of the Rating (1=low 6=high) in Europe(developing only) in 2008 to that in 2012?
Ensure brevity in your answer.  0.97. What is the ratio of the Rating (1=low 6=high) of Low income in 2008 to that in 2012?
Keep it short and to the point. 0.99. What is the ratio of the Rating (1=low 6=high) in Malawi in 2008 to that in 2012?
Make the answer very short. 1. What is the ratio of the Rating (1=low 6=high) of Yemen, Rep. in 2008 to that in 2012?
Your answer should be compact. 1. What is the ratio of the Rating (1=low 6=high) of Europe(developing only) in 2008 to that in 2013?
Provide a succinct answer. 0.97. What is the ratio of the Rating (1=low 6=high) of Malawi in 2008 to that in 2013?
Provide a succinct answer. 1. What is the ratio of the Rating (1=low 6=high) in Yemen, Rep. in 2008 to that in 2013?
Ensure brevity in your answer.  1. What is the ratio of the Rating (1=low 6=high) of Low income in 2009 to that in 2010?
Provide a succinct answer. 1. What is the ratio of the Rating (1=low 6=high) in Yemen, Rep. in 2009 to that in 2010?
Your response must be concise. 1. What is the ratio of the Rating (1=low 6=high) in Europe(developing only) in 2009 to that in 2011?
Your response must be concise. 1. What is the ratio of the Rating (1=low 6=high) in Low income in 2009 to that in 2011?
Your answer should be compact. 0.98. What is the ratio of the Rating (1=low 6=high) in Yemen, Rep. in 2009 to that in 2011?
Provide a short and direct response. 1. What is the ratio of the Rating (1=low 6=high) in Europe(developing only) in 2009 to that in 2012?
Offer a very short reply. 0.96. What is the ratio of the Rating (1=low 6=high) in Europe(developing only) in 2009 to that in 2013?
Provide a short and direct response. 0.96. What is the ratio of the Rating (1=low 6=high) in Low income in 2010 to that in 2011?
Keep it short and to the point. 0.98. What is the ratio of the Rating (1=low 6=high) in Europe(developing only) in 2010 to that in 2012?
Make the answer very short. 0.96. What is the ratio of the Rating (1=low 6=high) of Low income in 2010 to that in 2012?
Provide a succinct answer. 1. What is the ratio of the Rating (1=low 6=high) in Malawi in 2010 to that in 2012?
Give a very brief answer. 1. What is the ratio of the Rating (1=low 6=high) in Malawi in 2010 to that in 2013?
Provide a short and direct response. 1. What is the ratio of the Rating (1=low 6=high) in Europe(developing only) in 2011 to that in 2012?
Make the answer very short. 0.97. What is the ratio of the Rating (1=low 6=high) in Low income in 2011 to that in 2012?
Your answer should be compact. 1.01. What is the ratio of the Rating (1=low 6=high) of Europe(developing only) in 2011 to that in 2013?
Make the answer very short. 0.97. What is the ratio of the Rating (1=low 6=high) of Low income in 2011 to that in 2013?
Ensure brevity in your answer.  1.02. What is the ratio of the Rating (1=low 6=high) in Malawi in 2011 to that in 2013?
Your answer should be very brief. 1. What is the ratio of the Rating (1=low 6=high) in Yemen, Rep. in 2011 to that in 2013?
Provide a succinct answer. 1. What is the ratio of the Rating (1=low 6=high) of Europe(developing only) in 2012 to that in 2013?
Provide a short and direct response. 1. What is the ratio of the Rating (1=low 6=high) of Yemen, Rep. in 2012 to that in 2013?
Provide a short and direct response. 1. What is the difference between the highest and the second highest Rating (1=low 6=high) of Europe(developing only)?
Make the answer very short. 0. What is the difference between the highest and the second highest Rating (1=low 6=high) in Low income?
Your answer should be very brief. 0.04. What is the difference between the highest and the second highest Rating (1=low 6=high) in Yemen, Rep.?
Make the answer very short. 0. What is the difference between the highest and the lowest Rating (1=low 6=high) of Europe(developing only)?
Offer a terse response. 0.19. What is the difference between the highest and the lowest Rating (1=low 6=high) of Low income?
Offer a terse response. 0.16. What is the difference between the highest and the lowest Rating (1=low 6=high) of Malawi?
Ensure brevity in your answer.  0. 